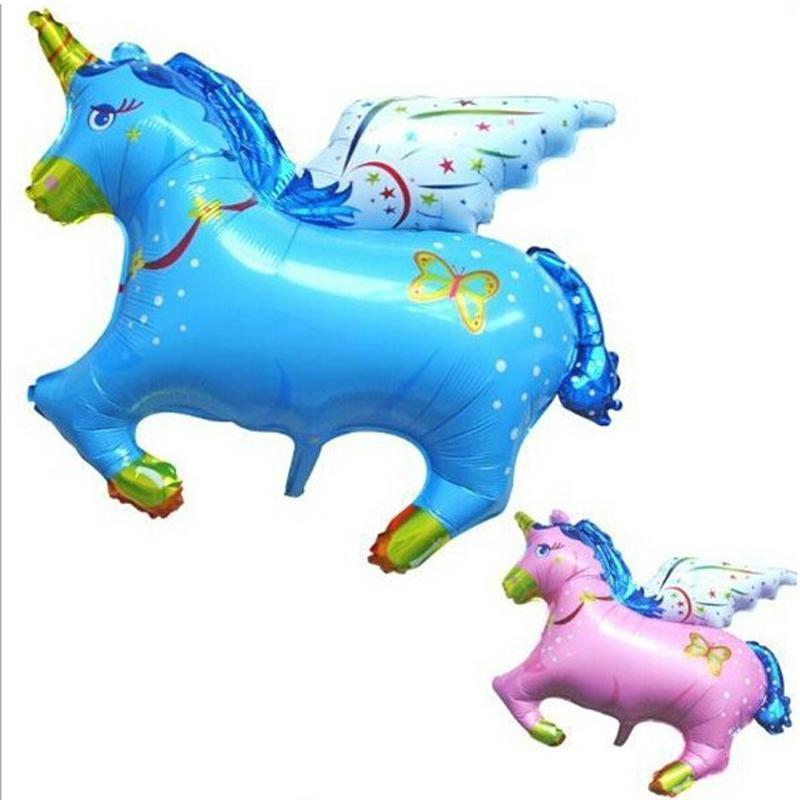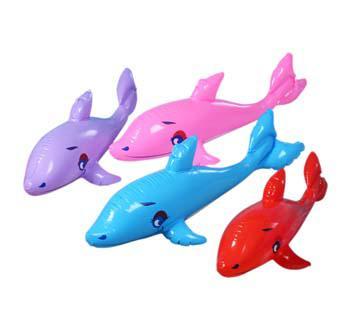The first image is the image on the left, the second image is the image on the right. Examine the images to the left and right. Is the description "There are no less than five balloons" accurate? Answer yes or no. Yes. 